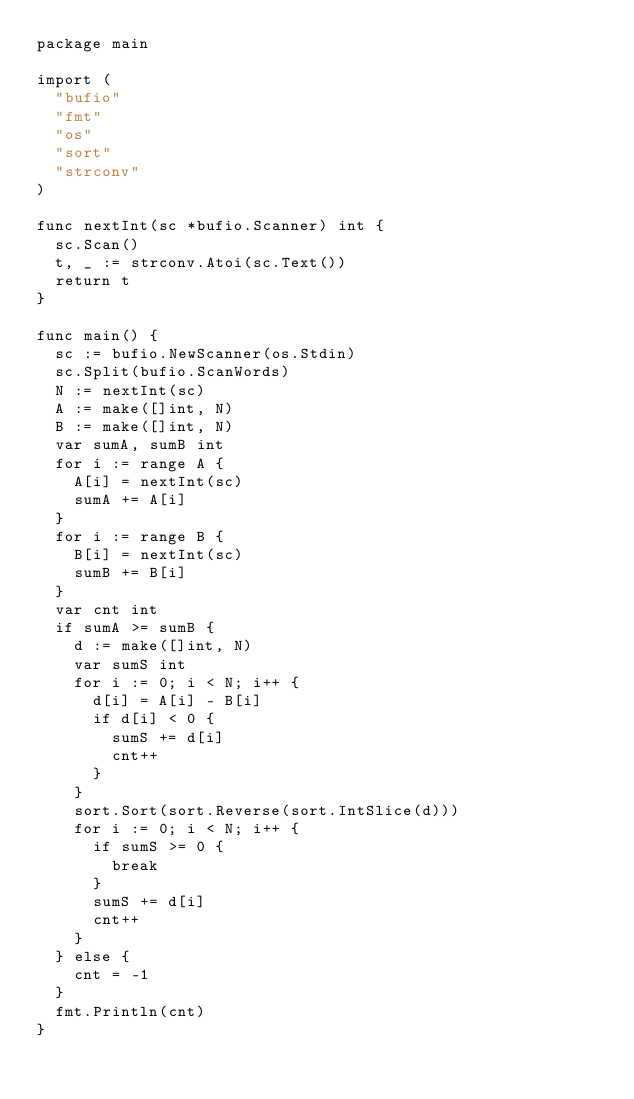Convert code to text. <code><loc_0><loc_0><loc_500><loc_500><_Go_>package main

import (
	"bufio"
	"fmt"
	"os"
	"sort"
	"strconv"
)

func nextInt(sc *bufio.Scanner) int {
	sc.Scan()
	t, _ := strconv.Atoi(sc.Text())
	return t
}

func main() {
	sc := bufio.NewScanner(os.Stdin)
	sc.Split(bufio.ScanWords)
	N := nextInt(sc)
	A := make([]int, N)
	B := make([]int, N)
	var sumA, sumB int
	for i := range A {
		A[i] = nextInt(sc)
		sumA += A[i]
	}
	for i := range B {
		B[i] = nextInt(sc)
		sumB += B[i]
	}
	var cnt int
	if sumA >= sumB {
		d := make([]int, N)
		var sumS int
		for i := 0; i < N; i++ {
			d[i] = A[i] - B[i]
			if d[i] < 0 {
				sumS += d[i]
				cnt++
			}
		}
		sort.Sort(sort.Reverse(sort.IntSlice(d)))
		for i := 0; i < N; i++ {
			if sumS >= 0 {
				break
			}
			sumS += d[i]
			cnt++
		}
	} else {
		cnt = -1
	}
	fmt.Println(cnt)
}
</code> 